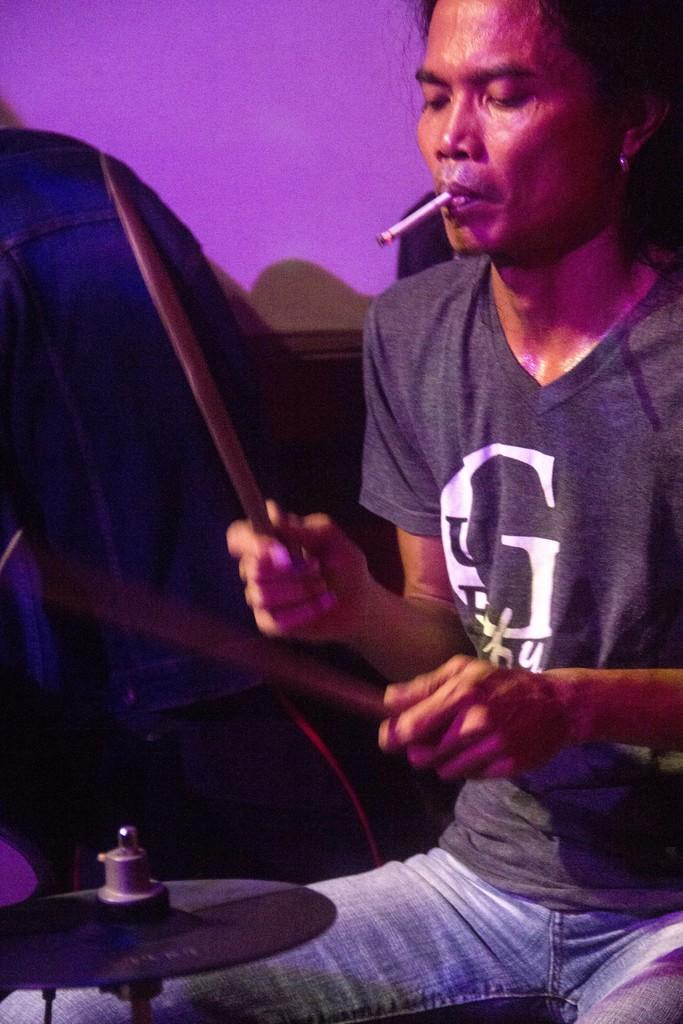<image>
Share a concise interpretation of the image provided. A man with a G on his shirt playing drums and smoking. 